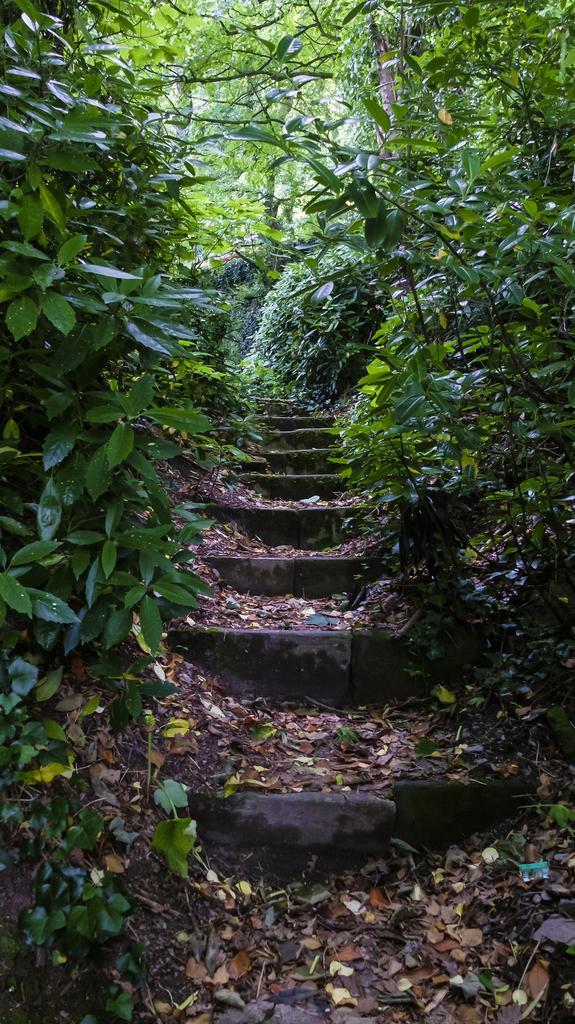In one or two sentences, can you explain what this image depicts? This picture is taken from the outside of the city. In this image, on the right side, we can see some trees and plants. On the left side, we can see some trees and plants. In the background, we can see some trees and plants. In the middle of the image, we can see a staircase with some leaves. 